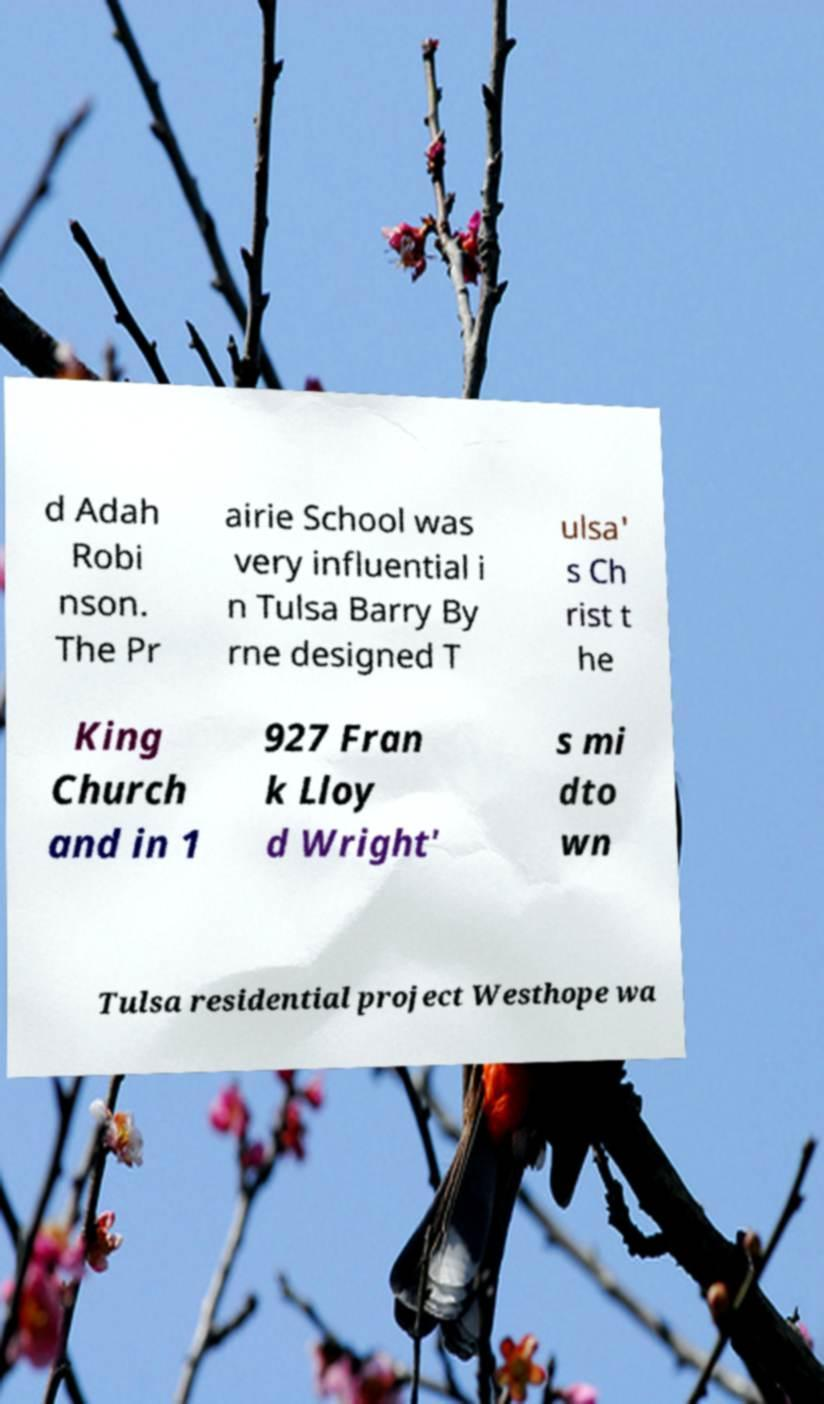Could you extract and type out the text from this image? d Adah Robi nson. The Pr airie School was very influential i n Tulsa Barry By rne designed T ulsa' s Ch rist t he King Church and in 1 927 Fran k Lloy d Wright' s mi dto wn Tulsa residential project Westhope wa 